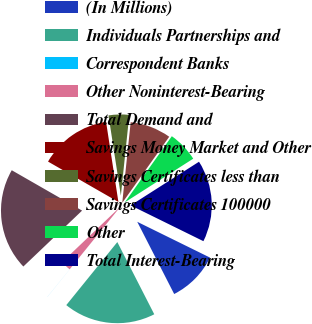Convert chart to OTSL. <chart><loc_0><loc_0><loc_500><loc_500><pie_chart><fcel>(In Millions)<fcel>Individuals Partnerships and<fcel>Correspondent Banks<fcel>Other Noninterest-Bearing<fcel>Total Demand and<fcel>Savings Money Market and Other<fcel>Savings Certificates less than<fcel>Savings Certificates 100000<fcel>Other<fcel>Total Interest-Bearing<nl><fcel>10.2%<fcel>18.36%<fcel>0.01%<fcel>2.05%<fcel>20.4%<fcel>14.28%<fcel>4.09%<fcel>8.17%<fcel>6.13%<fcel>16.32%<nl></chart> 